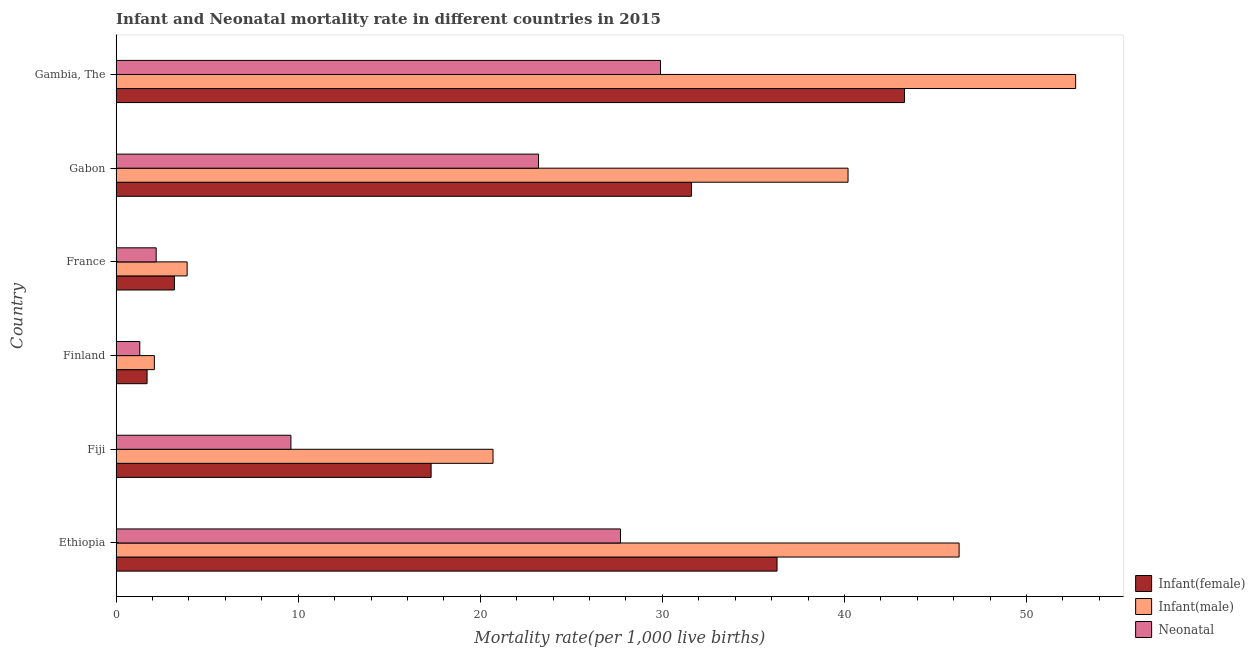How many different coloured bars are there?
Provide a succinct answer. 3. Are the number of bars on each tick of the Y-axis equal?
Make the answer very short. Yes. How many bars are there on the 3rd tick from the top?
Ensure brevity in your answer.  3. How many bars are there on the 6th tick from the bottom?
Ensure brevity in your answer.  3. What is the label of the 5th group of bars from the top?
Ensure brevity in your answer.  Fiji. In how many cases, is the number of bars for a given country not equal to the number of legend labels?
Give a very brief answer. 0. What is the infant mortality rate(male) in France?
Ensure brevity in your answer.  3.9. Across all countries, what is the maximum infant mortality rate(male)?
Offer a terse response. 52.7. In which country was the infant mortality rate(female) maximum?
Your answer should be very brief. Gambia, The. What is the total infant mortality rate(female) in the graph?
Make the answer very short. 133.4. What is the difference between the infant mortality rate(male) in Fiji and that in Gabon?
Make the answer very short. -19.5. What is the average neonatal mortality rate per country?
Keep it short and to the point. 15.65. What is the ratio of the infant mortality rate(male) in Fiji to that in Gabon?
Your answer should be compact. 0.52. Is the difference between the infant mortality rate(female) in Fiji and Gabon greater than the difference between the neonatal mortality rate in Fiji and Gabon?
Your answer should be compact. No. What is the difference between the highest and the lowest infant mortality rate(male)?
Provide a succinct answer. 50.6. What does the 3rd bar from the top in Finland represents?
Offer a terse response. Infant(female). What does the 2nd bar from the bottom in Ethiopia represents?
Ensure brevity in your answer.  Infant(male). Is it the case that in every country, the sum of the infant mortality rate(female) and infant mortality rate(male) is greater than the neonatal mortality rate?
Keep it short and to the point. Yes. How many bars are there?
Ensure brevity in your answer.  18. What is the difference between two consecutive major ticks on the X-axis?
Ensure brevity in your answer.  10. Does the graph contain any zero values?
Offer a terse response. No. Does the graph contain grids?
Offer a terse response. No. Where does the legend appear in the graph?
Your answer should be compact. Bottom right. How are the legend labels stacked?
Keep it short and to the point. Vertical. What is the title of the graph?
Provide a succinct answer. Infant and Neonatal mortality rate in different countries in 2015. Does "Financial account" appear as one of the legend labels in the graph?
Make the answer very short. No. What is the label or title of the X-axis?
Keep it short and to the point. Mortality rate(per 1,0 live births). What is the Mortality rate(per 1,000 live births) of Infant(female) in Ethiopia?
Make the answer very short. 36.3. What is the Mortality rate(per 1,000 live births) in Infant(male) in Ethiopia?
Make the answer very short. 46.3. What is the Mortality rate(per 1,000 live births) of Neonatal  in Ethiopia?
Your answer should be compact. 27.7. What is the Mortality rate(per 1,000 live births) in Infant(female) in Fiji?
Keep it short and to the point. 17.3. What is the Mortality rate(per 1,000 live births) of Infant(male) in Fiji?
Provide a short and direct response. 20.7. What is the Mortality rate(per 1,000 live births) of Neonatal  in Fiji?
Ensure brevity in your answer.  9.6. What is the Mortality rate(per 1,000 live births) in Infant(female) in Finland?
Your answer should be very brief. 1.7. What is the Mortality rate(per 1,000 live births) in Infant(male) in France?
Offer a terse response. 3.9. What is the Mortality rate(per 1,000 live births) of Neonatal  in France?
Ensure brevity in your answer.  2.2. What is the Mortality rate(per 1,000 live births) in Infant(female) in Gabon?
Your answer should be compact. 31.6. What is the Mortality rate(per 1,000 live births) of Infant(male) in Gabon?
Provide a short and direct response. 40.2. What is the Mortality rate(per 1,000 live births) in Neonatal  in Gabon?
Make the answer very short. 23.2. What is the Mortality rate(per 1,000 live births) of Infant(female) in Gambia, The?
Your answer should be compact. 43.3. What is the Mortality rate(per 1,000 live births) of Infant(male) in Gambia, The?
Keep it short and to the point. 52.7. What is the Mortality rate(per 1,000 live births) of Neonatal  in Gambia, The?
Keep it short and to the point. 29.9. Across all countries, what is the maximum Mortality rate(per 1,000 live births) of Infant(female)?
Offer a terse response. 43.3. Across all countries, what is the maximum Mortality rate(per 1,000 live births) of Infant(male)?
Provide a short and direct response. 52.7. Across all countries, what is the maximum Mortality rate(per 1,000 live births) of Neonatal ?
Offer a very short reply. 29.9. Across all countries, what is the minimum Mortality rate(per 1,000 live births) of Neonatal ?
Give a very brief answer. 1.3. What is the total Mortality rate(per 1,000 live births) of Infant(female) in the graph?
Ensure brevity in your answer.  133.4. What is the total Mortality rate(per 1,000 live births) in Infant(male) in the graph?
Give a very brief answer. 165.9. What is the total Mortality rate(per 1,000 live births) of Neonatal  in the graph?
Your answer should be compact. 93.9. What is the difference between the Mortality rate(per 1,000 live births) of Infant(male) in Ethiopia and that in Fiji?
Your answer should be very brief. 25.6. What is the difference between the Mortality rate(per 1,000 live births) of Neonatal  in Ethiopia and that in Fiji?
Offer a very short reply. 18.1. What is the difference between the Mortality rate(per 1,000 live births) of Infant(female) in Ethiopia and that in Finland?
Make the answer very short. 34.6. What is the difference between the Mortality rate(per 1,000 live births) of Infant(male) in Ethiopia and that in Finland?
Your answer should be compact. 44.2. What is the difference between the Mortality rate(per 1,000 live births) of Neonatal  in Ethiopia and that in Finland?
Make the answer very short. 26.4. What is the difference between the Mortality rate(per 1,000 live births) of Infant(female) in Ethiopia and that in France?
Your response must be concise. 33.1. What is the difference between the Mortality rate(per 1,000 live births) of Infant(male) in Ethiopia and that in France?
Provide a short and direct response. 42.4. What is the difference between the Mortality rate(per 1,000 live births) of Infant(female) in Ethiopia and that in Gabon?
Keep it short and to the point. 4.7. What is the difference between the Mortality rate(per 1,000 live births) of Infant(female) in Ethiopia and that in Gambia, The?
Provide a succinct answer. -7. What is the difference between the Mortality rate(per 1,000 live births) of Neonatal  in Ethiopia and that in Gambia, The?
Your answer should be compact. -2.2. What is the difference between the Mortality rate(per 1,000 live births) in Infant(female) in Fiji and that in Finland?
Provide a short and direct response. 15.6. What is the difference between the Mortality rate(per 1,000 live births) in Infant(male) in Fiji and that in Finland?
Keep it short and to the point. 18.6. What is the difference between the Mortality rate(per 1,000 live births) of Neonatal  in Fiji and that in Finland?
Provide a succinct answer. 8.3. What is the difference between the Mortality rate(per 1,000 live births) in Infant(female) in Fiji and that in France?
Your answer should be very brief. 14.1. What is the difference between the Mortality rate(per 1,000 live births) of Infant(male) in Fiji and that in France?
Make the answer very short. 16.8. What is the difference between the Mortality rate(per 1,000 live births) in Infant(female) in Fiji and that in Gabon?
Your response must be concise. -14.3. What is the difference between the Mortality rate(per 1,000 live births) of Infant(male) in Fiji and that in Gabon?
Provide a short and direct response. -19.5. What is the difference between the Mortality rate(per 1,000 live births) in Infant(male) in Fiji and that in Gambia, The?
Your response must be concise. -32. What is the difference between the Mortality rate(per 1,000 live births) in Neonatal  in Fiji and that in Gambia, The?
Offer a very short reply. -20.3. What is the difference between the Mortality rate(per 1,000 live births) in Infant(female) in Finland and that in France?
Your answer should be compact. -1.5. What is the difference between the Mortality rate(per 1,000 live births) of Infant(female) in Finland and that in Gabon?
Give a very brief answer. -29.9. What is the difference between the Mortality rate(per 1,000 live births) of Infant(male) in Finland and that in Gabon?
Provide a short and direct response. -38.1. What is the difference between the Mortality rate(per 1,000 live births) of Neonatal  in Finland and that in Gabon?
Provide a short and direct response. -21.9. What is the difference between the Mortality rate(per 1,000 live births) of Infant(female) in Finland and that in Gambia, The?
Give a very brief answer. -41.6. What is the difference between the Mortality rate(per 1,000 live births) of Infant(male) in Finland and that in Gambia, The?
Your answer should be very brief. -50.6. What is the difference between the Mortality rate(per 1,000 live births) in Neonatal  in Finland and that in Gambia, The?
Keep it short and to the point. -28.6. What is the difference between the Mortality rate(per 1,000 live births) in Infant(female) in France and that in Gabon?
Provide a short and direct response. -28.4. What is the difference between the Mortality rate(per 1,000 live births) of Infant(male) in France and that in Gabon?
Ensure brevity in your answer.  -36.3. What is the difference between the Mortality rate(per 1,000 live births) in Infant(female) in France and that in Gambia, The?
Keep it short and to the point. -40.1. What is the difference between the Mortality rate(per 1,000 live births) of Infant(male) in France and that in Gambia, The?
Offer a terse response. -48.8. What is the difference between the Mortality rate(per 1,000 live births) of Neonatal  in France and that in Gambia, The?
Offer a terse response. -27.7. What is the difference between the Mortality rate(per 1,000 live births) of Infant(female) in Gabon and that in Gambia, The?
Provide a succinct answer. -11.7. What is the difference between the Mortality rate(per 1,000 live births) in Infant(male) in Gabon and that in Gambia, The?
Your answer should be very brief. -12.5. What is the difference between the Mortality rate(per 1,000 live births) in Neonatal  in Gabon and that in Gambia, The?
Provide a short and direct response. -6.7. What is the difference between the Mortality rate(per 1,000 live births) in Infant(female) in Ethiopia and the Mortality rate(per 1,000 live births) in Infant(male) in Fiji?
Provide a succinct answer. 15.6. What is the difference between the Mortality rate(per 1,000 live births) of Infant(female) in Ethiopia and the Mortality rate(per 1,000 live births) of Neonatal  in Fiji?
Keep it short and to the point. 26.7. What is the difference between the Mortality rate(per 1,000 live births) of Infant(male) in Ethiopia and the Mortality rate(per 1,000 live births) of Neonatal  in Fiji?
Your answer should be very brief. 36.7. What is the difference between the Mortality rate(per 1,000 live births) of Infant(female) in Ethiopia and the Mortality rate(per 1,000 live births) of Infant(male) in Finland?
Make the answer very short. 34.2. What is the difference between the Mortality rate(per 1,000 live births) of Infant(female) in Ethiopia and the Mortality rate(per 1,000 live births) of Neonatal  in Finland?
Offer a very short reply. 35. What is the difference between the Mortality rate(per 1,000 live births) of Infant(male) in Ethiopia and the Mortality rate(per 1,000 live births) of Neonatal  in Finland?
Your response must be concise. 45. What is the difference between the Mortality rate(per 1,000 live births) of Infant(female) in Ethiopia and the Mortality rate(per 1,000 live births) of Infant(male) in France?
Provide a short and direct response. 32.4. What is the difference between the Mortality rate(per 1,000 live births) of Infant(female) in Ethiopia and the Mortality rate(per 1,000 live births) of Neonatal  in France?
Ensure brevity in your answer.  34.1. What is the difference between the Mortality rate(per 1,000 live births) of Infant(male) in Ethiopia and the Mortality rate(per 1,000 live births) of Neonatal  in France?
Your response must be concise. 44.1. What is the difference between the Mortality rate(per 1,000 live births) of Infant(male) in Ethiopia and the Mortality rate(per 1,000 live births) of Neonatal  in Gabon?
Provide a short and direct response. 23.1. What is the difference between the Mortality rate(per 1,000 live births) of Infant(female) in Ethiopia and the Mortality rate(per 1,000 live births) of Infant(male) in Gambia, The?
Your answer should be very brief. -16.4. What is the difference between the Mortality rate(per 1,000 live births) of Infant(female) in Ethiopia and the Mortality rate(per 1,000 live births) of Neonatal  in Gambia, The?
Give a very brief answer. 6.4. What is the difference between the Mortality rate(per 1,000 live births) of Infant(male) in Ethiopia and the Mortality rate(per 1,000 live births) of Neonatal  in Gambia, The?
Provide a short and direct response. 16.4. What is the difference between the Mortality rate(per 1,000 live births) in Infant(male) in Fiji and the Mortality rate(per 1,000 live births) in Neonatal  in Finland?
Your answer should be compact. 19.4. What is the difference between the Mortality rate(per 1,000 live births) of Infant(female) in Fiji and the Mortality rate(per 1,000 live births) of Infant(male) in France?
Your answer should be very brief. 13.4. What is the difference between the Mortality rate(per 1,000 live births) in Infant(female) in Fiji and the Mortality rate(per 1,000 live births) in Neonatal  in France?
Provide a succinct answer. 15.1. What is the difference between the Mortality rate(per 1,000 live births) in Infant(male) in Fiji and the Mortality rate(per 1,000 live births) in Neonatal  in France?
Give a very brief answer. 18.5. What is the difference between the Mortality rate(per 1,000 live births) in Infant(female) in Fiji and the Mortality rate(per 1,000 live births) in Infant(male) in Gabon?
Make the answer very short. -22.9. What is the difference between the Mortality rate(per 1,000 live births) of Infant(female) in Fiji and the Mortality rate(per 1,000 live births) of Neonatal  in Gabon?
Your answer should be compact. -5.9. What is the difference between the Mortality rate(per 1,000 live births) in Infant(male) in Fiji and the Mortality rate(per 1,000 live births) in Neonatal  in Gabon?
Keep it short and to the point. -2.5. What is the difference between the Mortality rate(per 1,000 live births) of Infant(female) in Fiji and the Mortality rate(per 1,000 live births) of Infant(male) in Gambia, The?
Make the answer very short. -35.4. What is the difference between the Mortality rate(per 1,000 live births) of Infant(male) in Fiji and the Mortality rate(per 1,000 live births) of Neonatal  in Gambia, The?
Keep it short and to the point. -9.2. What is the difference between the Mortality rate(per 1,000 live births) of Infant(female) in Finland and the Mortality rate(per 1,000 live births) of Infant(male) in France?
Ensure brevity in your answer.  -2.2. What is the difference between the Mortality rate(per 1,000 live births) of Infant(female) in Finland and the Mortality rate(per 1,000 live births) of Infant(male) in Gabon?
Your answer should be very brief. -38.5. What is the difference between the Mortality rate(per 1,000 live births) of Infant(female) in Finland and the Mortality rate(per 1,000 live births) of Neonatal  in Gabon?
Offer a terse response. -21.5. What is the difference between the Mortality rate(per 1,000 live births) in Infant(male) in Finland and the Mortality rate(per 1,000 live births) in Neonatal  in Gabon?
Give a very brief answer. -21.1. What is the difference between the Mortality rate(per 1,000 live births) in Infant(female) in Finland and the Mortality rate(per 1,000 live births) in Infant(male) in Gambia, The?
Make the answer very short. -51. What is the difference between the Mortality rate(per 1,000 live births) in Infant(female) in Finland and the Mortality rate(per 1,000 live births) in Neonatal  in Gambia, The?
Ensure brevity in your answer.  -28.2. What is the difference between the Mortality rate(per 1,000 live births) of Infant(male) in Finland and the Mortality rate(per 1,000 live births) of Neonatal  in Gambia, The?
Give a very brief answer. -27.8. What is the difference between the Mortality rate(per 1,000 live births) in Infant(female) in France and the Mortality rate(per 1,000 live births) in Infant(male) in Gabon?
Provide a short and direct response. -37. What is the difference between the Mortality rate(per 1,000 live births) in Infant(female) in France and the Mortality rate(per 1,000 live births) in Neonatal  in Gabon?
Make the answer very short. -20. What is the difference between the Mortality rate(per 1,000 live births) of Infant(male) in France and the Mortality rate(per 1,000 live births) of Neonatal  in Gabon?
Offer a terse response. -19.3. What is the difference between the Mortality rate(per 1,000 live births) of Infant(female) in France and the Mortality rate(per 1,000 live births) of Infant(male) in Gambia, The?
Your answer should be compact. -49.5. What is the difference between the Mortality rate(per 1,000 live births) in Infant(female) in France and the Mortality rate(per 1,000 live births) in Neonatal  in Gambia, The?
Your answer should be compact. -26.7. What is the difference between the Mortality rate(per 1,000 live births) of Infant(male) in France and the Mortality rate(per 1,000 live births) of Neonatal  in Gambia, The?
Offer a very short reply. -26. What is the difference between the Mortality rate(per 1,000 live births) of Infant(female) in Gabon and the Mortality rate(per 1,000 live births) of Infant(male) in Gambia, The?
Give a very brief answer. -21.1. What is the average Mortality rate(per 1,000 live births) of Infant(female) per country?
Offer a very short reply. 22.23. What is the average Mortality rate(per 1,000 live births) of Infant(male) per country?
Provide a succinct answer. 27.65. What is the average Mortality rate(per 1,000 live births) of Neonatal  per country?
Provide a succinct answer. 15.65. What is the difference between the Mortality rate(per 1,000 live births) in Infant(male) and Mortality rate(per 1,000 live births) in Neonatal  in Ethiopia?
Your answer should be compact. 18.6. What is the difference between the Mortality rate(per 1,000 live births) of Infant(female) and Mortality rate(per 1,000 live births) of Neonatal  in Fiji?
Provide a succinct answer. 7.7. What is the difference between the Mortality rate(per 1,000 live births) of Infant(female) and Mortality rate(per 1,000 live births) of Infant(male) in France?
Offer a very short reply. -0.7. What is the difference between the Mortality rate(per 1,000 live births) in Infant(female) and Mortality rate(per 1,000 live births) in Neonatal  in France?
Your response must be concise. 1. What is the difference between the Mortality rate(per 1,000 live births) of Infant(female) and Mortality rate(per 1,000 live births) of Infant(male) in Gabon?
Ensure brevity in your answer.  -8.6. What is the difference between the Mortality rate(per 1,000 live births) of Infant(male) and Mortality rate(per 1,000 live births) of Neonatal  in Gabon?
Your answer should be very brief. 17. What is the difference between the Mortality rate(per 1,000 live births) in Infant(female) and Mortality rate(per 1,000 live births) in Neonatal  in Gambia, The?
Offer a very short reply. 13.4. What is the difference between the Mortality rate(per 1,000 live births) of Infant(male) and Mortality rate(per 1,000 live births) of Neonatal  in Gambia, The?
Offer a very short reply. 22.8. What is the ratio of the Mortality rate(per 1,000 live births) of Infant(female) in Ethiopia to that in Fiji?
Make the answer very short. 2.1. What is the ratio of the Mortality rate(per 1,000 live births) in Infant(male) in Ethiopia to that in Fiji?
Ensure brevity in your answer.  2.24. What is the ratio of the Mortality rate(per 1,000 live births) of Neonatal  in Ethiopia to that in Fiji?
Keep it short and to the point. 2.89. What is the ratio of the Mortality rate(per 1,000 live births) in Infant(female) in Ethiopia to that in Finland?
Keep it short and to the point. 21.35. What is the ratio of the Mortality rate(per 1,000 live births) in Infant(male) in Ethiopia to that in Finland?
Ensure brevity in your answer.  22.05. What is the ratio of the Mortality rate(per 1,000 live births) in Neonatal  in Ethiopia to that in Finland?
Make the answer very short. 21.31. What is the ratio of the Mortality rate(per 1,000 live births) in Infant(female) in Ethiopia to that in France?
Your answer should be compact. 11.34. What is the ratio of the Mortality rate(per 1,000 live births) in Infant(male) in Ethiopia to that in France?
Offer a terse response. 11.87. What is the ratio of the Mortality rate(per 1,000 live births) in Neonatal  in Ethiopia to that in France?
Give a very brief answer. 12.59. What is the ratio of the Mortality rate(per 1,000 live births) of Infant(female) in Ethiopia to that in Gabon?
Provide a short and direct response. 1.15. What is the ratio of the Mortality rate(per 1,000 live births) of Infant(male) in Ethiopia to that in Gabon?
Keep it short and to the point. 1.15. What is the ratio of the Mortality rate(per 1,000 live births) of Neonatal  in Ethiopia to that in Gabon?
Provide a short and direct response. 1.19. What is the ratio of the Mortality rate(per 1,000 live births) of Infant(female) in Ethiopia to that in Gambia, The?
Provide a succinct answer. 0.84. What is the ratio of the Mortality rate(per 1,000 live births) in Infant(male) in Ethiopia to that in Gambia, The?
Make the answer very short. 0.88. What is the ratio of the Mortality rate(per 1,000 live births) of Neonatal  in Ethiopia to that in Gambia, The?
Offer a terse response. 0.93. What is the ratio of the Mortality rate(per 1,000 live births) in Infant(female) in Fiji to that in Finland?
Ensure brevity in your answer.  10.18. What is the ratio of the Mortality rate(per 1,000 live births) of Infant(male) in Fiji to that in Finland?
Offer a terse response. 9.86. What is the ratio of the Mortality rate(per 1,000 live births) in Neonatal  in Fiji to that in Finland?
Offer a very short reply. 7.38. What is the ratio of the Mortality rate(per 1,000 live births) in Infant(female) in Fiji to that in France?
Your answer should be compact. 5.41. What is the ratio of the Mortality rate(per 1,000 live births) in Infant(male) in Fiji to that in France?
Provide a short and direct response. 5.31. What is the ratio of the Mortality rate(per 1,000 live births) of Neonatal  in Fiji to that in France?
Ensure brevity in your answer.  4.36. What is the ratio of the Mortality rate(per 1,000 live births) of Infant(female) in Fiji to that in Gabon?
Keep it short and to the point. 0.55. What is the ratio of the Mortality rate(per 1,000 live births) of Infant(male) in Fiji to that in Gabon?
Keep it short and to the point. 0.51. What is the ratio of the Mortality rate(per 1,000 live births) in Neonatal  in Fiji to that in Gabon?
Provide a succinct answer. 0.41. What is the ratio of the Mortality rate(per 1,000 live births) of Infant(female) in Fiji to that in Gambia, The?
Your answer should be very brief. 0.4. What is the ratio of the Mortality rate(per 1,000 live births) of Infant(male) in Fiji to that in Gambia, The?
Ensure brevity in your answer.  0.39. What is the ratio of the Mortality rate(per 1,000 live births) in Neonatal  in Fiji to that in Gambia, The?
Your answer should be compact. 0.32. What is the ratio of the Mortality rate(per 1,000 live births) in Infant(female) in Finland to that in France?
Keep it short and to the point. 0.53. What is the ratio of the Mortality rate(per 1,000 live births) of Infant(male) in Finland to that in France?
Your answer should be compact. 0.54. What is the ratio of the Mortality rate(per 1,000 live births) in Neonatal  in Finland to that in France?
Keep it short and to the point. 0.59. What is the ratio of the Mortality rate(per 1,000 live births) in Infant(female) in Finland to that in Gabon?
Ensure brevity in your answer.  0.05. What is the ratio of the Mortality rate(per 1,000 live births) of Infant(male) in Finland to that in Gabon?
Ensure brevity in your answer.  0.05. What is the ratio of the Mortality rate(per 1,000 live births) in Neonatal  in Finland to that in Gabon?
Ensure brevity in your answer.  0.06. What is the ratio of the Mortality rate(per 1,000 live births) in Infant(female) in Finland to that in Gambia, The?
Give a very brief answer. 0.04. What is the ratio of the Mortality rate(per 1,000 live births) in Infant(male) in Finland to that in Gambia, The?
Your answer should be very brief. 0.04. What is the ratio of the Mortality rate(per 1,000 live births) of Neonatal  in Finland to that in Gambia, The?
Provide a succinct answer. 0.04. What is the ratio of the Mortality rate(per 1,000 live births) of Infant(female) in France to that in Gabon?
Provide a succinct answer. 0.1. What is the ratio of the Mortality rate(per 1,000 live births) in Infant(male) in France to that in Gabon?
Offer a terse response. 0.1. What is the ratio of the Mortality rate(per 1,000 live births) of Neonatal  in France to that in Gabon?
Offer a very short reply. 0.09. What is the ratio of the Mortality rate(per 1,000 live births) of Infant(female) in France to that in Gambia, The?
Offer a very short reply. 0.07. What is the ratio of the Mortality rate(per 1,000 live births) of Infant(male) in France to that in Gambia, The?
Provide a succinct answer. 0.07. What is the ratio of the Mortality rate(per 1,000 live births) in Neonatal  in France to that in Gambia, The?
Your answer should be compact. 0.07. What is the ratio of the Mortality rate(per 1,000 live births) of Infant(female) in Gabon to that in Gambia, The?
Provide a short and direct response. 0.73. What is the ratio of the Mortality rate(per 1,000 live births) of Infant(male) in Gabon to that in Gambia, The?
Your response must be concise. 0.76. What is the ratio of the Mortality rate(per 1,000 live births) of Neonatal  in Gabon to that in Gambia, The?
Provide a succinct answer. 0.78. What is the difference between the highest and the second highest Mortality rate(per 1,000 live births) of Infant(female)?
Keep it short and to the point. 7. What is the difference between the highest and the second highest Mortality rate(per 1,000 live births) in Infant(male)?
Provide a short and direct response. 6.4. What is the difference between the highest and the lowest Mortality rate(per 1,000 live births) of Infant(female)?
Your response must be concise. 41.6. What is the difference between the highest and the lowest Mortality rate(per 1,000 live births) of Infant(male)?
Offer a very short reply. 50.6. What is the difference between the highest and the lowest Mortality rate(per 1,000 live births) in Neonatal ?
Your answer should be very brief. 28.6. 